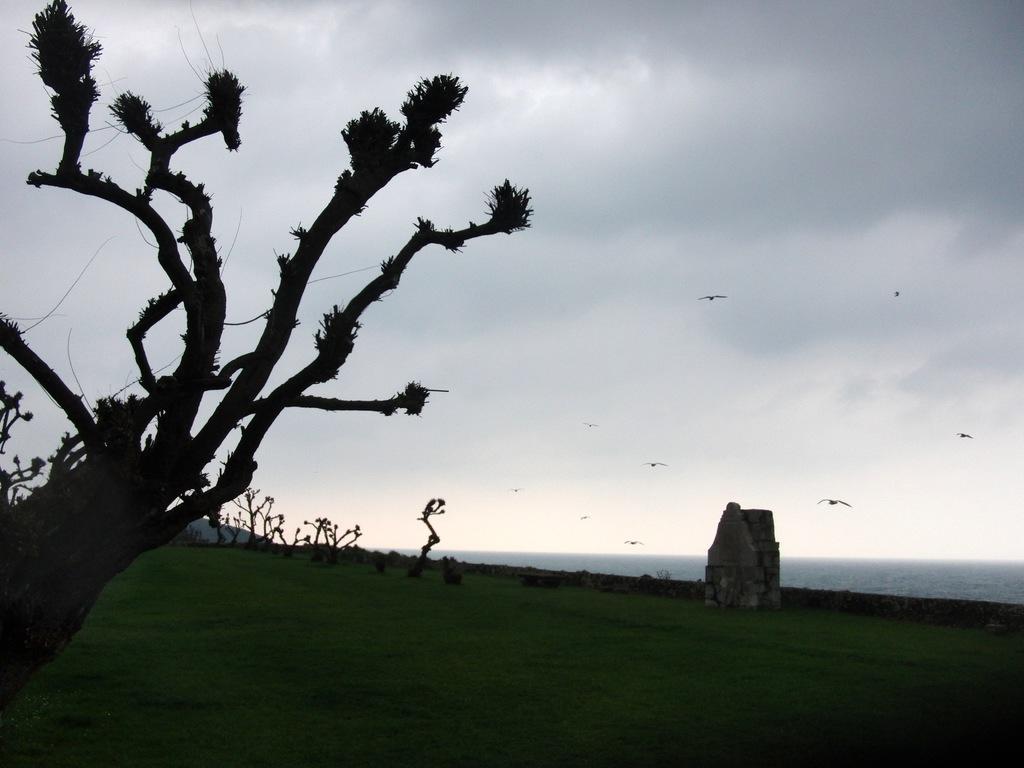Please provide a concise description of this image. In the image there is a tree in the foreground, around the tree there is a lot of grass and in the background there are trees and there is a stone beside trees. 